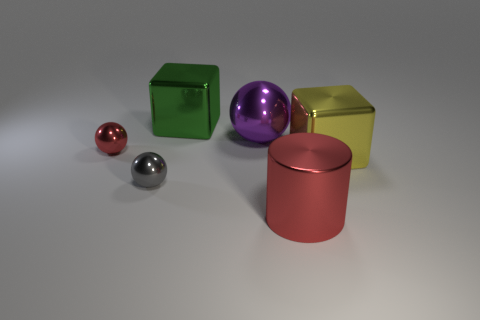How big is the cylinder?
Your response must be concise. Large. What number of objects are either brown rubber blocks or large metallic cubes?
Your response must be concise. 2. There is a big sphere that is made of the same material as the cylinder; what color is it?
Your answer should be very brief. Purple. Is the shape of the object behind the purple metallic ball the same as  the purple shiny thing?
Your response must be concise. No. How many things are either large things to the left of the big red metal object or red things that are on the left side of the large red shiny cylinder?
Provide a succinct answer. 3. What is the color of the other big thing that is the same shape as the gray metal object?
Provide a short and direct response. Purple. Is there anything else that has the same shape as the purple thing?
Your response must be concise. Yes. Is the shape of the large green metal object the same as the red shiny thing in front of the big yellow shiny cube?
Give a very brief answer. No. What material is the yellow thing?
Ensure brevity in your answer.  Metal. There is a red shiny thing that is the same shape as the gray shiny object; what size is it?
Your answer should be very brief. Small. 